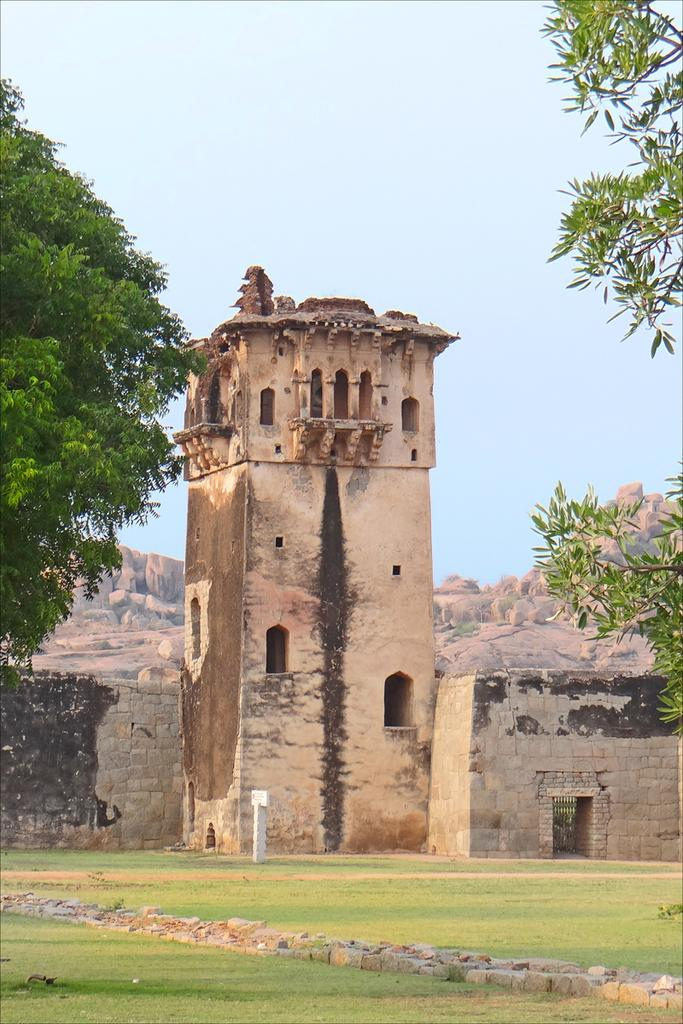What type of vegetation is present in the image? There is green grass in the image. What type of structure can be seen in the image? There is a fort in the image. What other natural elements are visible in the image? There are trees and mountains in the image. What is visible in the sky in the image? There are clouds in the sky in the image. How many chickens are present in the image? There are no chickens present in the image. What company is responsible for the construction of the fort in the image? The image does not provide information about the company responsible for the construction of the fort. 